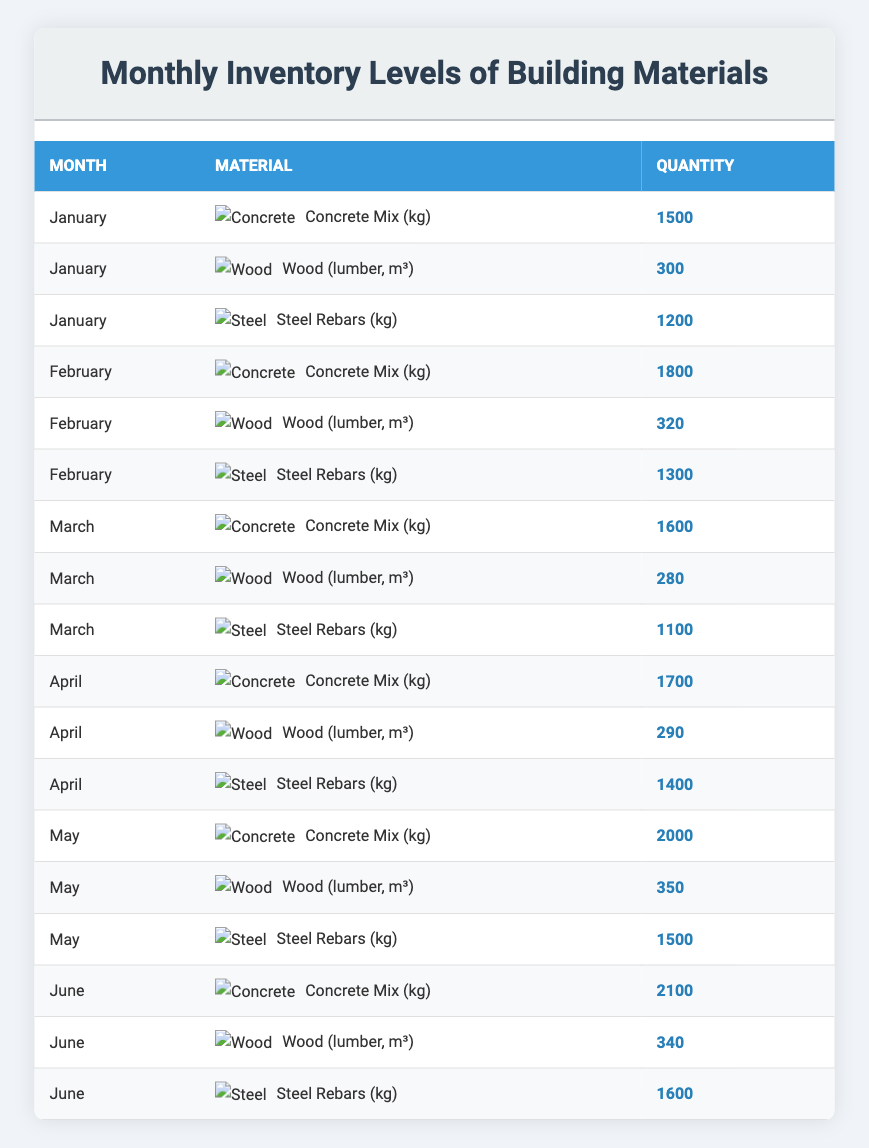What was the quantity of Concrete Mix in March? From the table, I find the entry for March and look at the material listed as Concrete Mix, whose quantity is provided as 1600 kg.
Answer: 1600 kg In which month was the highest quantity of Wood (lumber) recorded? I review the quantities of Wood (lumber) for each month: January (300 m³), February (320 m³), March (280 m³), April (290 m³), May (350 m³), and June (340 m³). The highest value is found in May with 350 m³.
Answer: May What is the total quantity of Steel Rebars from January to April? I add the quantities for Steel Rebars for the months: January (1200 kg), February (1300 kg), March (1100 kg), and April (1400 kg). Summing these gives 1200 + 1300 + 1100 + 1400 = 5000 kg.
Answer: 5000 kg Is the quantity of Concrete Mix in June higher than in February? In the table, June shows a Concrete Mix quantity of 2100 kg, while February shows 1800 kg. Since 2100 kg is greater than 1800 kg, the statement is true.
Answer: Yes What is the average quantity of Wood (lumber) across all six months? First, I gather the quantities: January (300 m³), February (320 m³), March (280 m³), April (290 m³), May (350 m³), June (340 m³). Adding these gives 300 + 320 + 280 + 290 + 350 + 340 = 1880 m³. Since there are 6 months, the average is 1880 / 6 = 313.33 m³.
Answer: 313.33 m³ Which month experienced the highest increase in Concrete Mix quantity compared to the previous month? Comparing the quantities from month to month, January to February is an increase of 300 kg (1800 - 1500), February to March a decrease of 200 kg (1600 - 1800), March to April an increase of 100 kg (1700 - 1600), April to May an increase of 300 kg (2000 - 1700), and May to June an increase of 100 kg (2100 - 2000). The highest increase is from April to May at 300 kg.
Answer: April to May Was there ever a month where the quantity of Steel Rebars was less than 1000 kg? Looking through the Steel Rebars quantities for each month: January (1200 kg), February (1300 kg), March (1100 kg), April (1400 kg), May (1500 kg), June (1600 kg). All values are greater than 1000 kg, thus the statement is false.
Answer: No 